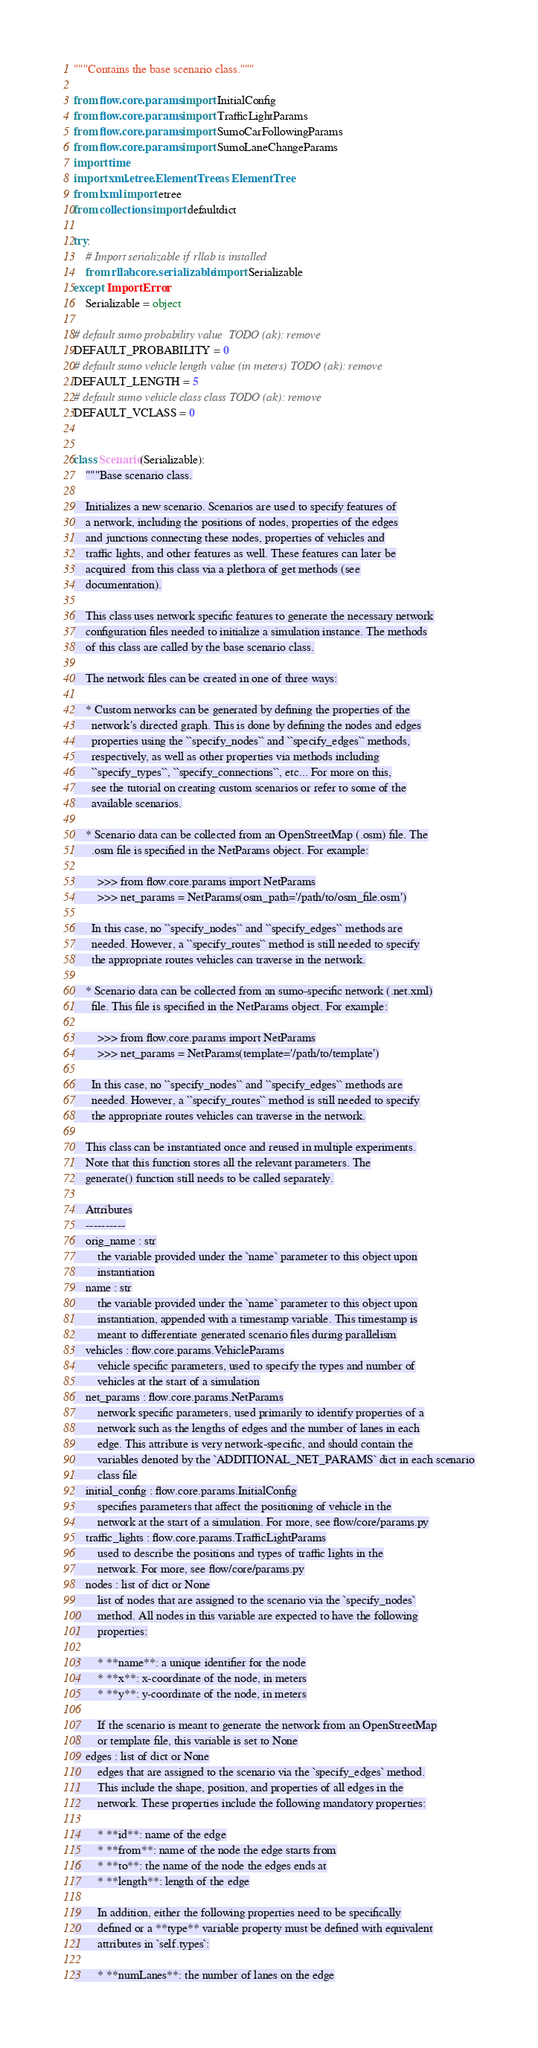Convert code to text. <code><loc_0><loc_0><loc_500><loc_500><_Python_>"""Contains the base scenario class."""

from flow.core.params import InitialConfig
from flow.core.params import TrafficLightParams
from flow.core.params import SumoCarFollowingParams
from flow.core.params import SumoLaneChangeParams
import time
import xml.etree.ElementTree as ElementTree
from lxml import etree
from collections import defaultdict

try:
    # Import serializable if rllab is installed
    from rllab.core.serializable import Serializable
except ImportError:
    Serializable = object

# default sumo probability value  TODO (ak): remove
DEFAULT_PROBABILITY = 0
# default sumo vehicle length value (in meters) TODO (ak): remove
DEFAULT_LENGTH = 5
# default sumo vehicle class class TODO (ak): remove
DEFAULT_VCLASS = 0


class Scenario(Serializable):
    """Base scenario class.

    Initializes a new scenario. Scenarios are used to specify features of
    a network, including the positions of nodes, properties of the edges
    and junctions connecting these nodes, properties of vehicles and
    traffic lights, and other features as well. These features can later be
    acquired  from this class via a plethora of get methods (see
    documentation).

    This class uses network specific features to generate the necessary network
    configuration files needed to initialize a simulation instance. The methods
    of this class are called by the base scenario class.

    The network files can be created in one of three ways:

    * Custom networks can be generated by defining the properties of the
      network's directed graph. This is done by defining the nodes and edges
      properties using the ``specify_nodes`` and ``specify_edges`` methods,
      respectively, as well as other properties via methods including
      ``specify_types``, ``specify_connections``, etc... For more on this,
      see the tutorial on creating custom scenarios or refer to some of the
      available scenarios.

    * Scenario data can be collected from an OpenStreetMap (.osm) file. The
      .osm file is specified in the NetParams object. For example:

        >>> from flow.core.params import NetParams
        >>> net_params = NetParams(osm_path='/path/to/osm_file.osm')

      In this case, no ``specify_nodes`` and ``specify_edges`` methods are
      needed. However, a ``specify_routes`` method is still needed to specify
      the appropriate routes vehicles can traverse in the network.

    * Scenario data can be collected from an sumo-specific network (.net.xml)
      file. This file is specified in the NetParams object. For example:

        >>> from flow.core.params import NetParams
        >>> net_params = NetParams(template='/path/to/template')

      In this case, no ``specify_nodes`` and ``specify_edges`` methods are
      needed. However, a ``specify_routes`` method is still needed to specify
      the appropriate routes vehicles can traverse in the network.

    This class can be instantiated once and reused in multiple experiments.
    Note that this function stores all the relevant parameters. The
    generate() function still needs to be called separately.

    Attributes
    ----------
    orig_name : str
        the variable provided under the `name` parameter to this object upon
        instantiation
    name : str
        the variable provided under the `name` parameter to this object upon
        instantiation, appended with a timestamp variable. This timestamp is
        meant to differentiate generated scenario files during parallelism
    vehicles : flow.core.params.VehicleParams
        vehicle specific parameters, used to specify the types and number of
        vehicles at the start of a simulation
    net_params : flow.core.params.NetParams
        network specific parameters, used primarily to identify properties of a
        network such as the lengths of edges and the number of lanes in each
        edge. This attribute is very network-specific, and should contain the
        variables denoted by the `ADDITIONAL_NET_PARAMS` dict in each scenario
        class file
    initial_config : flow.core.params.InitialConfig
        specifies parameters that affect the positioning of vehicle in the
        network at the start of a simulation. For more, see flow/core/params.py
    traffic_lights : flow.core.params.TrafficLightParams
        used to describe the positions and types of traffic lights in the
        network. For more, see flow/core/params.py
    nodes : list of dict or None
        list of nodes that are assigned to the scenario via the `specify_nodes`
        method. All nodes in this variable are expected to have the following
        properties:

        * **name**: a unique identifier for the node
        * **x**: x-coordinate of the node, in meters
        * **y**: y-coordinate of the node, in meters

        If the scenario is meant to generate the network from an OpenStreetMap
        or template file, this variable is set to None
    edges : list of dict or None
        edges that are assigned to the scenario via the `specify_edges` method.
        This include the shape, position, and properties of all edges in the
        network. These properties include the following mandatory properties:

        * **id**: name of the edge
        * **from**: name of the node the edge starts from
        * **to**: the name of the node the edges ends at
        * **length**: length of the edge

        In addition, either the following properties need to be specifically
        defined or a **type** variable property must be defined with equivalent
        attributes in `self.types`:

        * **numLanes**: the number of lanes on the edge</code> 